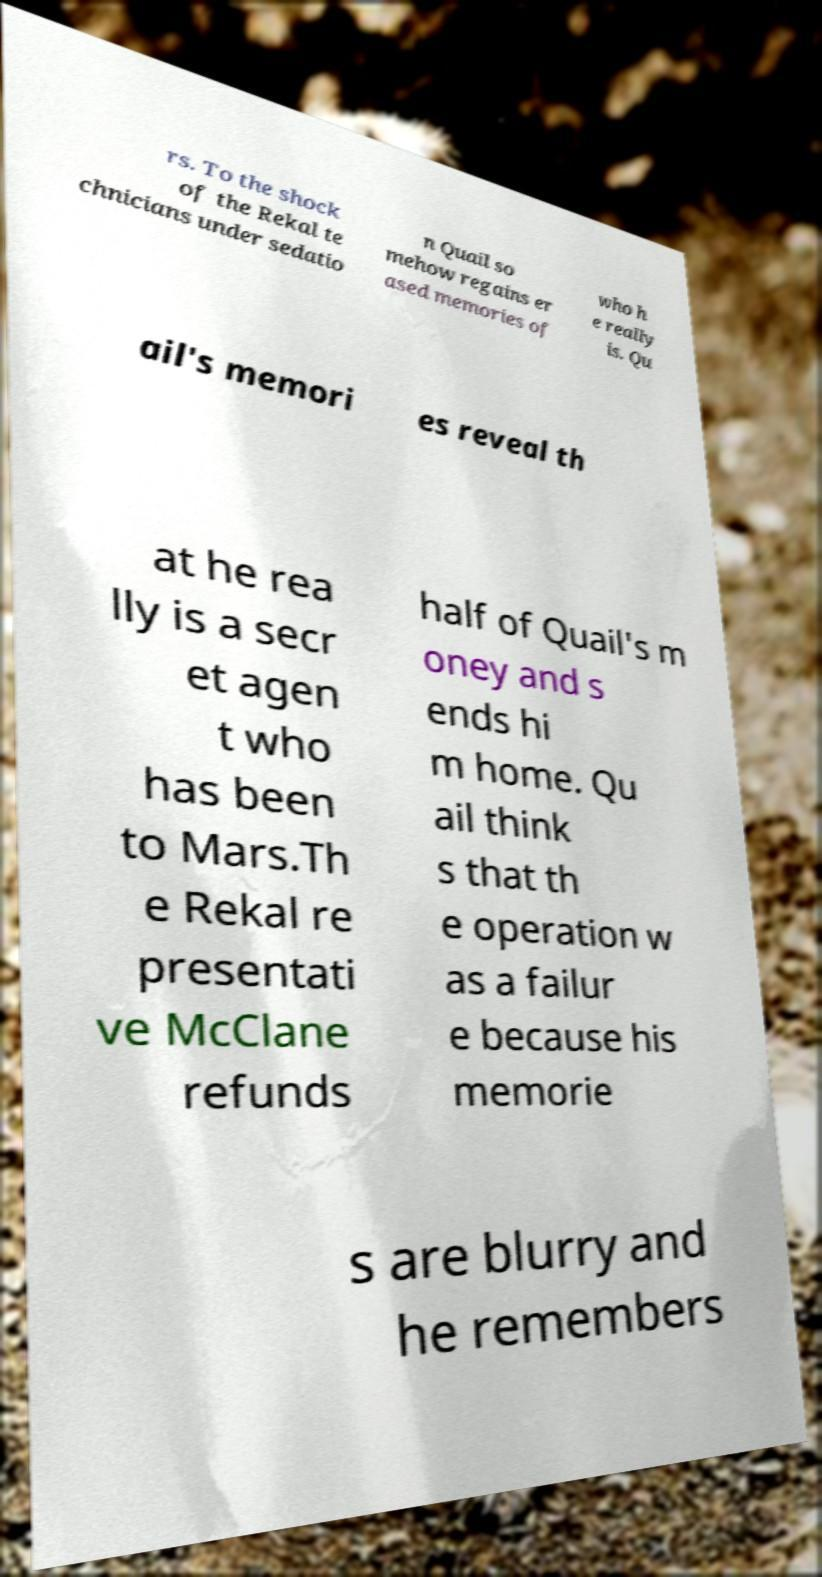Can you read and provide the text displayed in the image?This photo seems to have some interesting text. Can you extract and type it out for me? rs. To the shock of the Rekal te chnicians under sedatio n Quail so mehow regains er ased memories of who h e really is. Qu ail's memori es reveal th at he rea lly is a secr et agen t who has been to Mars.Th e Rekal re presentati ve McClane refunds half of Quail's m oney and s ends hi m home. Qu ail think s that th e operation w as a failur e because his memorie s are blurry and he remembers 